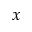Convert formula to latex. <formula><loc_0><loc_0><loc_500><loc_500>x</formula> 